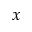Convert formula to latex. <formula><loc_0><loc_0><loc_500><loc_500>x</formula> 